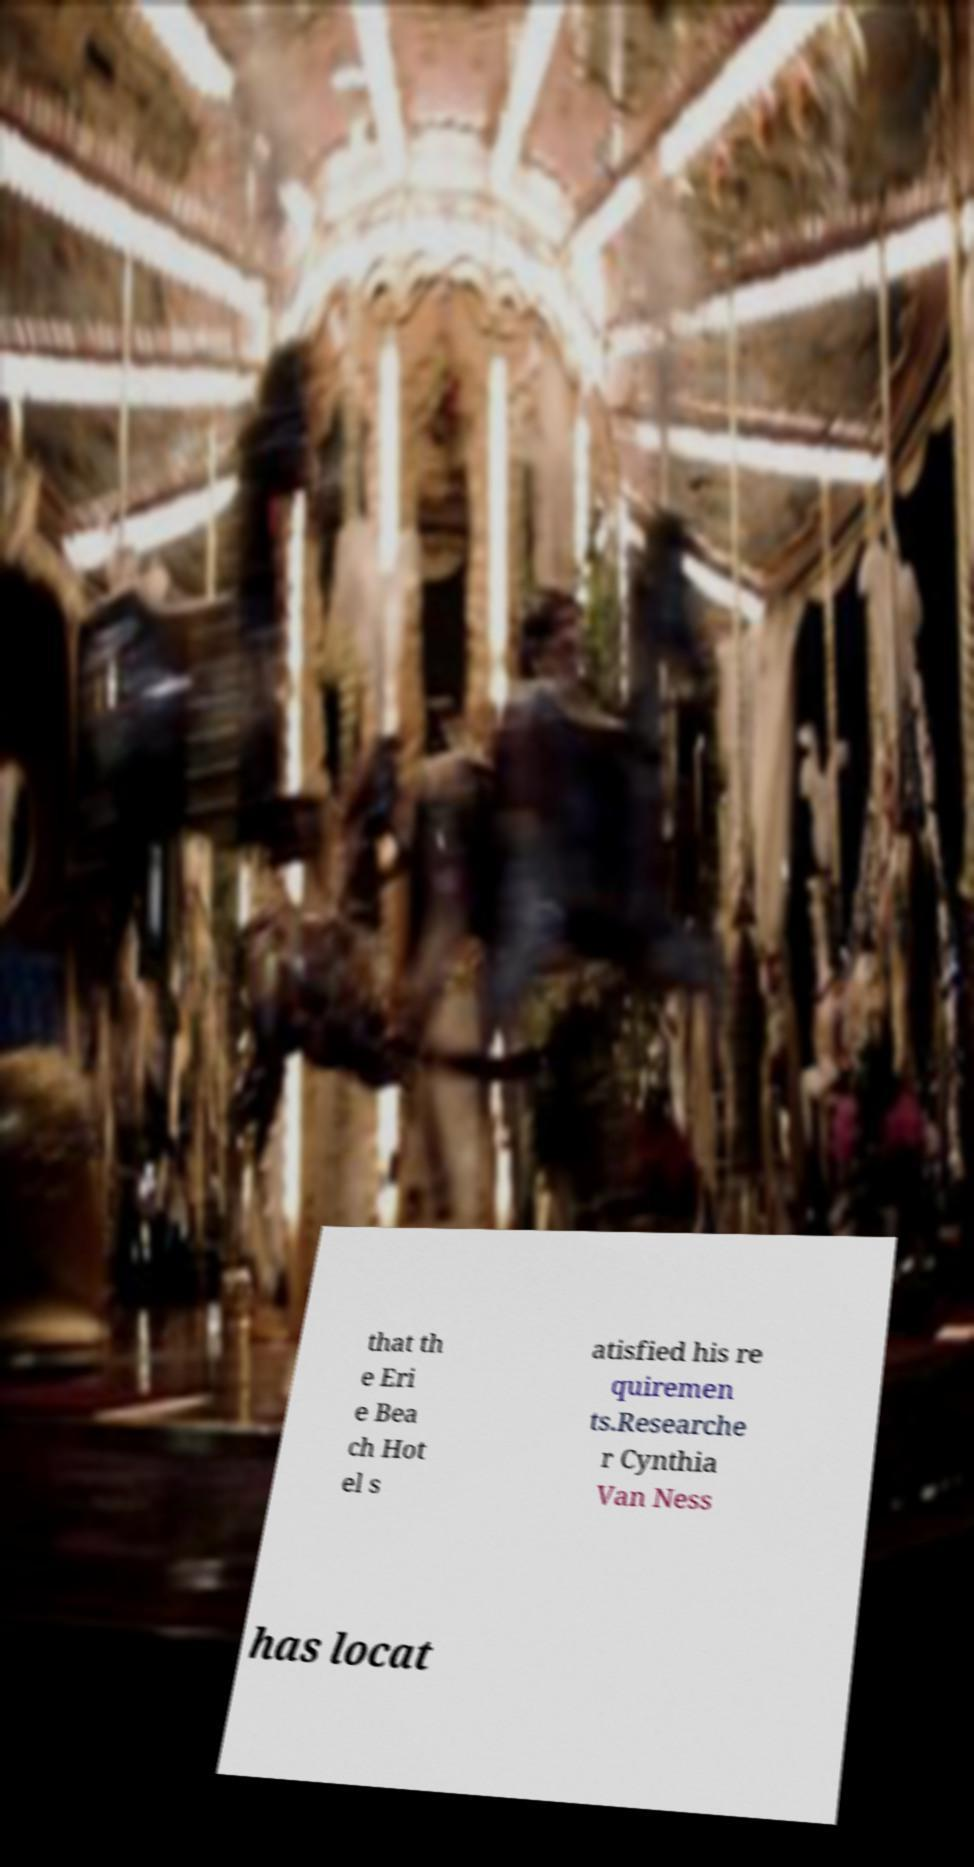There's text embedded in this image that I need extracted. Can you transcribe it verbatim? that th e Eri e Bea ch Hot el s atisfied his re quiremen ts.Researche r Cynthia Van Ness has locat 